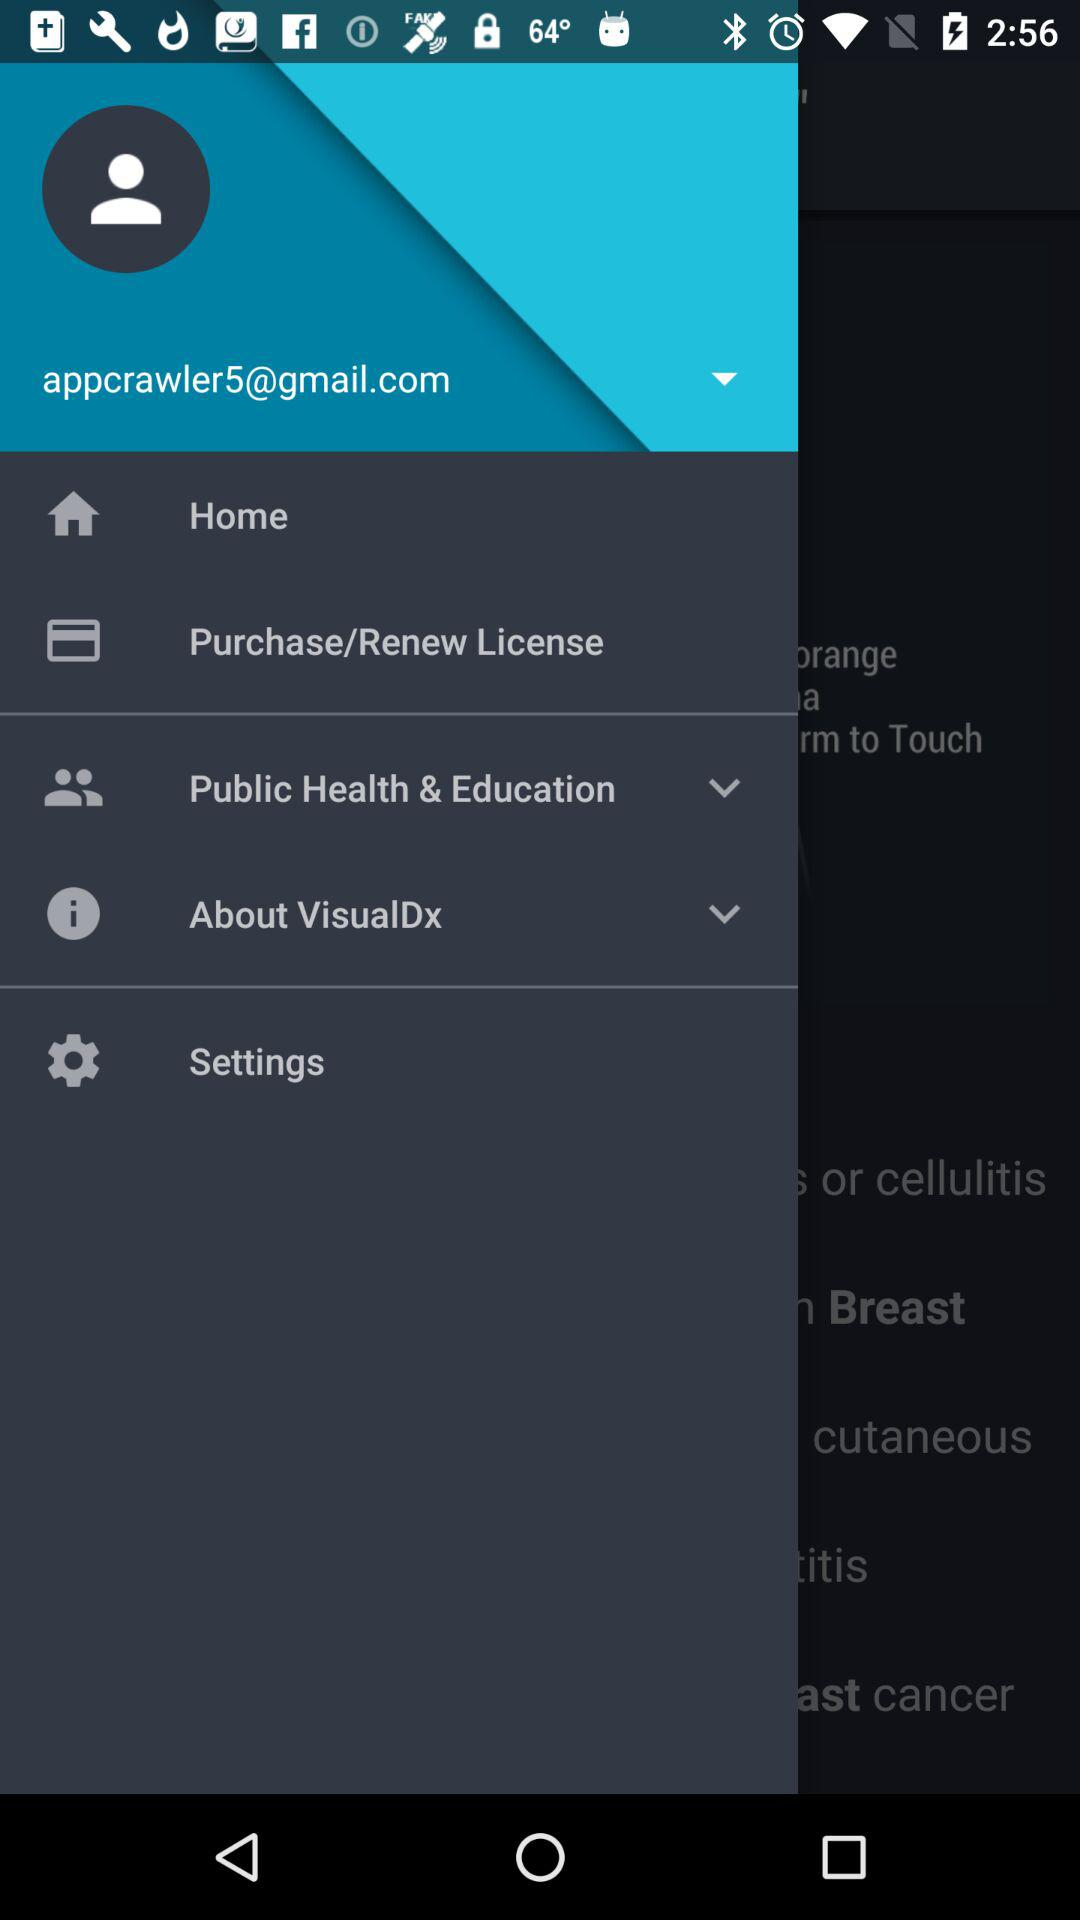What is the email address? The email address is appcrawler5@gmail.com. 